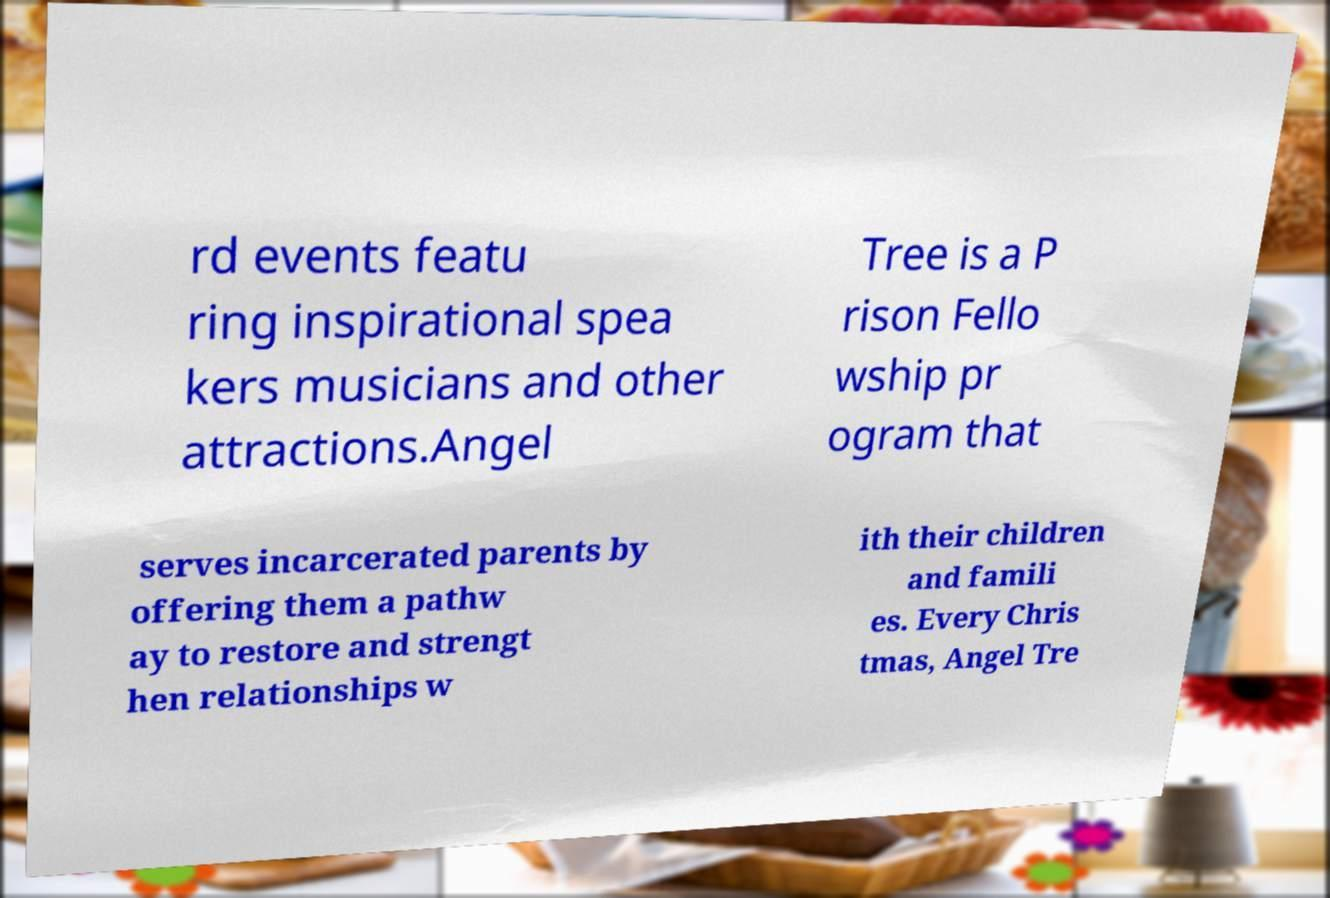Could you assist in decoding the text presented in this image and type it out clearly? rd events featu ring inspirational spea kers musicians and other attractions.Angel Tree is a P rison Fello wship pr ogram that serves incarcerated parents by offering them a pathw ay to restore and strengt hen relationships w ith their children and famili es. Every Chris tmas, Angel Tre 